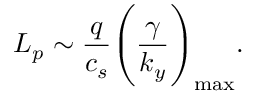<formula> <loc_0><loc_0><loc_500><loc_500>L _ { p } \sim \frac { q } { c _ { s } } \left ( \frac { \gamma } { k _ { y } } \right ) _ { \max } .</formula> 